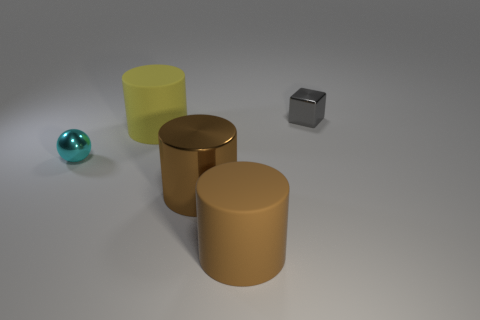Add 4 yellow rubber cylinders. How many objects exist? 9 Subtract all cylinders. How many objects are left? 2 Subtract all cylinders. Subtract all cyan balls. How many objects are left? 1 Add 4 large brown objects. How many large brown objects are left? 6 Add 5 brown metallic things. How many brown metallic things exist? 6 Subtract 0 yellow blocks. How many objects are left? 5 